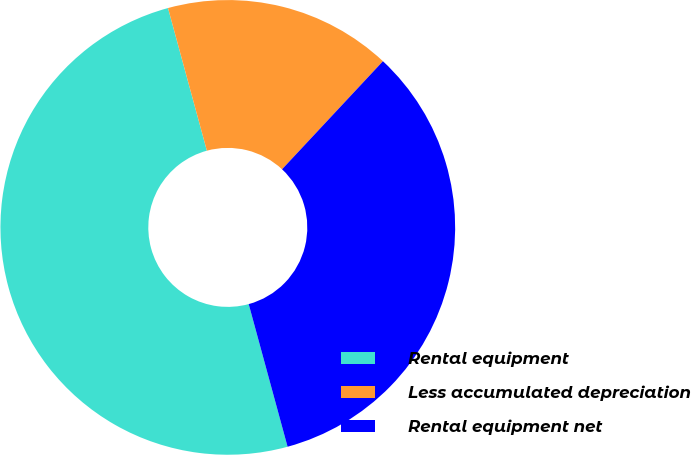Convert chart to OTSL. <chart><loc_0><loc_0><loc_500><loc_500><pie_chart><fcel>Rental equipment<fcel>Less accumulated depreciation<fcel>Rental equipment net<nl><fcel>50.0%<fcel>16.19%<fcel>33.81%<nl></chart> 